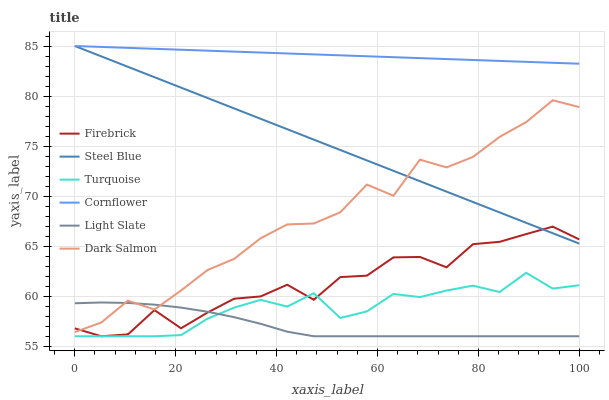Does Light Slate have the minimum area under the curve?
Answer yes or no. Yes. Does Cornflower have the maximum area under the curve?
Answer yes or no. Yes. Does Turquoise have the minimum area under the curve?
Answer yes or no. No. Does Turquoise have the maximum area under the curve?
Answer yes or no. No. Is Cornflower the smoothest?
Answer yes or no. Yes. Is Firebrick the roughest?
Answer yes or no. Yes. Is Turquoise the smoothest?
Answer yes or no. No. Is Turquoise the roughest?
Answer yes or no. No. Does Turquoise have the lowest value?
Answer yes or no. Yes. Does Steel Blue have the lowest value?
Answer yes or no. No. Does Steel Blue have the highest value?
Answer yes or no. Yes. Does Turquoise have the highest value?
Answer yes or no. No. Is Turquoise less than Steel Blue?
Answer yes or no. Yes. Is Cornflower greater than Turquoise?
Answer yes or no. Yes. Does Steel Blue intersect Firebrick?
Answer yes or no. Yes. Is Steel Blue less than Firebrick?
Answer yes or no. No. Is Steel Blue greater than Firebrick?
Answer yes or no. No. Does Turquoise intersect Steel Blue?
Answer yes or no. No. 